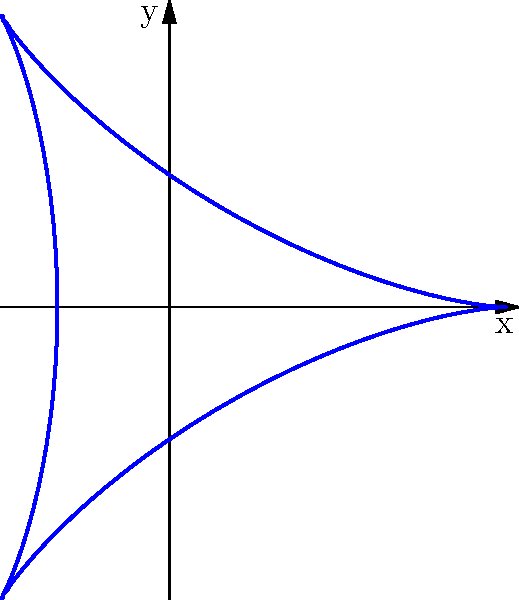A race track layout is modeled by the parametric equations:
$$x(t) = 2\cos(t) + \cos(2t)$$
$$y(t) = 2\sin(t) - \sin(2t)$$
where $0 \leq t \leq 2\pi$. Calculate the area enclosed by this curve using Green's theorem. To calculate the area enclosed by a parametric curve using Green's theorem, we can use the formula:

$$\text{Area} = \frac{1}{2} \oint (x dy - y dx)$$

1) First, we need to find $dx$ and $dy$:
   $$dx = (-2\sin(t) - 2\sin(2t))dt$$
   $$dy = (2\cos(t) - 2\cos(2t))dt$$

2) Now, we substitute these into our area formula:
   $$\text{Area} = \frac{1}{2} \int_0^{2\pi} [(2\cos(t) + \cos(2t))(2\cos(t) - 2\cos(2t)) - (2\sin(t) - \sin(2t))(-2\sin(t) - 2\sin(2t))] dt$$

3) Expand the integrand:
   $$\text{Area} = \frac{1}{2} \int_0^{2\pi} [4\cos^2(t) - 2\cos(t)\cos(2t) + 2\cos(t)\cos(2t) - 2\cos^2(2t) + 4\sin^2(t) + 2\sin(t)\sin(2t) - 2\sin(t)\sin(2t) - 2\sin^2(2t)] dt$$

4) Simplify:
   $$\text{Area} = \frac{1}{2} \int_0^{2\pi} [4\cos^2(t) + 4\sin^2(t) - 2\cos^2(2t) - 2\sin^2(2t)] dt$$

5) Use trigonometric identities:
   $$\text{Area} = \frac{1}{2} \int_0^{2\pi} [4 - 2(\cos^2(2t) + \sin^2(2t))] dt = \frac{1}{2} \int_0^{2\pi} [4 - 2] dt = \int_0^{2\pi} dt$$

6) Evaluate the integral:
   $$\text{Area} = [t]_0^{2\pi} = 2\pi$$

Therefore, the area enclosed by the curve is $2\pi$ square units.
Answer: $2\pi$ square units 